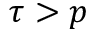<formula> <loc_0><loc_0><loc_500><loc_500>\tau > p</formula> 